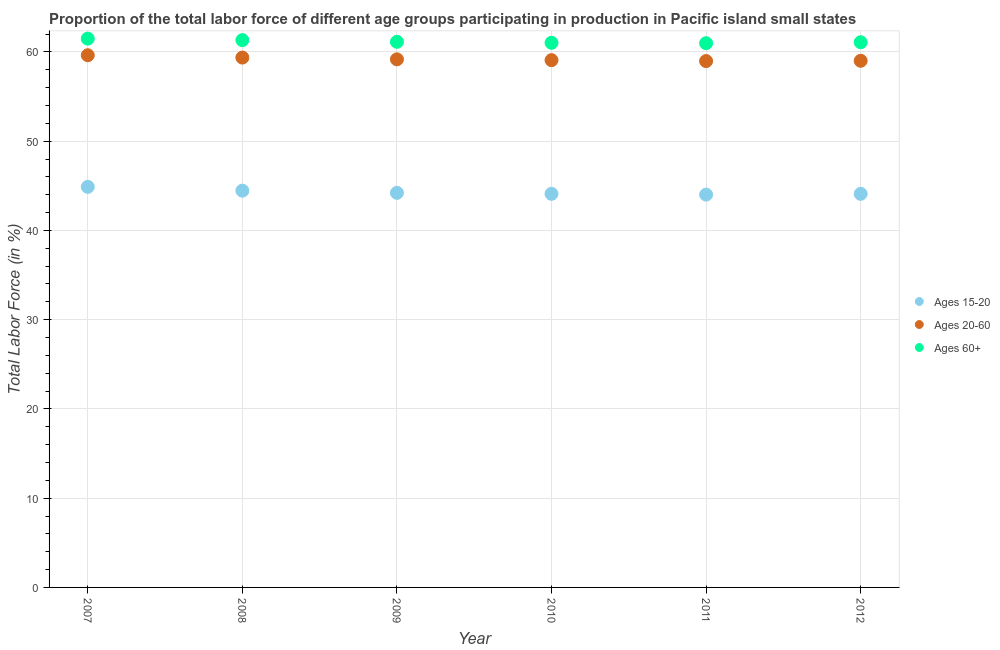What is the percentage of labor force within the age group 20-60 in 2010?
Keep it short and to the point. 59.08. Across all years, what is the maximum percentage of labor force above age 60?
Offer a very short reply. 61.49. Across all years, what is the minimum percentage of labor force within the age group 15-20?
Your answer should be very brief. 44.01. In which year was the percentage of labor force within the age group 20-60 maximum?
Offer a terse response. 2007. In which year was the percentage of labor force within the age group 20-60 minimum?
Provide a short and direct response. 2011. What is the total percentage of labor force above age 60 in the graph?
Provide a short and direct response. 367.02. What is the difference between the percentage of labor force within the age group 15-20 in 2008 and that in 2009?
Your response must be concise. 0.24. What is the difference between the percentage of labor force above age 60 in 2007 and the percentage of labor force within the age group 15-20 in 2008?
Make the answer very short. 17.04. What is the average percentage of labor force within the age group 20-60 per year?
Make the answer very short. 59.2. In the year 2012, what is the difference between the percentage of labor force within the age group 15-20 and percentage of labor force above age 60?
Make the answer very short. -16.99. What is the ratio of the percentage of labor force above age 60 in 2007 to that in 2010?
Your answer should be compact. 1.01. What is the difference between the highest and the second highest percentage of labor force within the age group 20-60?
Provide a short and direct response. 0.26. What is the difference between the highest and the lowest percentage of labor force within the age group 20-60?
Give a very brief answer. 0.65. In how many years, is the percentage of labor force within the age group 15-20 greater than the average percentage of labor force within the age group 15-20 taken over all years?
Provide a short and direct response. 2. Is it the case that in every year, the sum of the percentage of labor force within the age group 15-20 and percentage of labor force within the age group 20-60 is greater than the percentage of labor force above age 60?
Keep it short and to the point. Yes. How many years are there in the graph?
Ensure brevity in your answer.  6. Are the values on the major ticks of Y-axis written in scientific E-notation?
Your response must be concise. No. Does the graph contain any zero values?
Your answer should be very brief. No. Where does the legend appear in the graph?
Ensure brevity in your answer.  Center right. How many legend labels are there?
Your answer should be very brief. 3. What is the title of the graph?
Your response must be concise. Proportion of the total labor force of different age groups participating in production in Pacific island small states. What is the Total Labor Force (in %) of Ages 15-20 in 2007?
Your answer should be compact. 44.88. What is the Total Labor Force (in %) in Ages 20-60 in 2007?
Your response must be concise. 59.63. What is the Total Labor Force (in %) in Ages 60+ in 2007?
Keep it short and to the point. 61.49. What is the Total Labor Force (in %) in Ages 15-20 in 2008?
Your response must be concise. 44.45. What is the Total Labor Force (in %) in Ages 20-60 in 2008?
Your response must be concise. 59.36. What is the Total Labor Force (in %) of Ages 60+ in 2008?
Provide a succinct answer. 61.32. What is the Total Labor Force (in %) in Ages 15-20 in 2009?
Your answer should be compact. 44.21. What is the Total Labor Force (in %) of Ages 20-60 in 2009?
Provide a succinct answer. 59.17. What is the Total Labor Force (in %) in Ages 60+ in 2009?
Ensure brevity in your answer.  61.13. What is the Total Labor Force (in %) in Ages 15-20 in 2010?
Give a very brief answer. 44.1. What is the Total Labor Force (in %) of Ages 20-60 in 2010?
Keep it short and to the point. 59.08. What is the Total Labor Force (in %) in Ages 60+ in 2010?
Offer a terse response. 61.02. What is the Total Labor Force (in %) of Ages 15-20 in 2011?
Provide a succinct answer. 44.01. What is the Total Labor Force (in %) in Ages 20-60 in 2011?
Your response must be concise. 58.97. What is the Total Labor Force (in %) of Ages 60+ in 2011?
Make the answer very short. 60.97. What is the Total Labor Force (in %) in Ages 15-20 in 2012?
Offer a terse response. 44.1. What is the Total Labor Force (in %) of Ages 20-60 in 2012?
Provide a short and direct response. 59.01. What is the Total Labor Force (in %) of Ages 60+ in 2012?
Your answer should be compact. 61.09. Across all years, what is the maximum Total Labor Force (in %) in Ages 15-20?
Keep it short and to the point. 44.88. Across all years, what is the maximum Total Labor Force (in %) of Ages 20-60?
Ensure brevity in your answer.  59.63. Across all years, what is the maximum Total Labor Force (in %) of Ages 60+?
Keep it short and to the point. 61.49. Across all years, what is the minimum Total Labor Force (in %) in Ages 15-20?
Keep it short and to the point. 44.01. Across all years, what is the minimum Total Labor Force (in %) in Ages 20-60?
Provide a succinct answer. 58.97. Across all years, what is the minimum Total Labor Force (in %) in Ages 60+?
Make the answer very short. 60.97. What is the total Total Labor Force (in %) in Ages 15-20 in the graph?
Ensure brevity in your answer.  265.75. What is the total Total Labor Force (in %) in Ages 20-60 in the graph?
Give a very brief answer. 355.22. What is the total Total Labor Force (in %) in Ages 60+ in the graph?
Your response must be concise. 367.02. What is the difference between the Total Labor Force (in %) of Ages 15-20 in 2007 and that in 2008?
Offer a terse response. 0.43. What is the difference between the Total Labor Force (in %) in Ages 20-60 in 2007 and that in 2008?
Ensure brevity in your answer.  0.26. What is the difference between the Total Labor Force (in %) in Ages 60+ in 2007 and that in 2008?
Make the answer very short. 0.17. What is the difference between the Total Labor Force (in %) in Ages 15-20 in 2007 and that in 2009?
Offer a very short reply. 0.67. What is the difference between the Total Labor Force (in %) in Ages 20-60 in 2007 and that in 2009?
Your response must be concise. 0.46. What is the difference between the Total Labor Force (in %) in Ages 60+ in 2007 and that in 2009?
Provide a succinct answer. 0.36. What is the difference between the Total Labor Force (in %) of Ages 15-20 in 2007 and that in 2010?
Your answer should be very brief. 0.78. What is the difference between the Total Labor Force (in %) of Ages 20-60 in 2007 and that in 2010?
Keep it short and to the point. 0.55. What is the difference between the Total Labor Force (in %) in Ages 60+ in 2007 and that in 2010?
Provide a short and direct response. 0.47. What is the difference between the Total Labor Force (in %) in Ages 15-20 in 2007 and that in 2011?
Make the answer very short. 0.87. What is the difference between the Total Labor Force (in %) of Ages 20-60 in 2007 and that in 2011?
Your answer should be compact. 0.65. What is the difference between the Total Labor Force (in %) of Ages 60+ in 2007 and that in 2011?
Offer a terse response. 0.51. What is the difference between the Total Labor Force (in %) of Ages 15-20 in 2007 and that in 2012?
Offer a very short reply. 0.78. What is the difference between the Total Labor Force (in %) of Ages 20-60 in 2007 and that in 2012?
Keep it short and to the point. 0.62. What is the difference between the Total Labor Force (in %) in Ages 60+ in 2007 and that in 2012?
Provide a short and direct response. 0.4. What is the difference between the Total Labor Force (in %) in Ages 15-20 in 2008 and that in 2009?
Make the answer very short. 0.24. What is the difference between the Total Labor Force (in %) in Ages 20-60 in 2008 and that in 2009?
Provide a succinct answer. 0.2. What is the difference between the Total Labor Force (in %) of Ages 60+ in 2008 and that in 2009?
Your answer should be very brief. 0.19. What is the difference between the Total Labor Force (in %) in Ages 15-20 in 2008 and that in 2010?
Provide a succinct answer. 0.35. What is the difference between the Total Labor Force (in %) in Ages 20-60 in 2008 and that in 2010?
Provide a short and direct response. 0.29. What is the difference between the Total Labor Force (in %) of Ages 60+ in 2008 and that in 2010?
Ensure brevity in your answer.  0.3. What is the difference between the Total Labor Force (in %) of Ages 15-20 in 2008 and that in 2011?
Your answer should be compact. 0.44. What is the difference between the Total Labor Force (in %) in Ages 20-60 in 2008 and that in 2011?
Provide a short and direct response. 0.39. What is the difference between the Total Labor Force (in %) in Ages 60+ in 2008 and that in 2011?
Provide a succinct answer. 0.35. What is the difference between the Total Labor Force (in %) of Ages 15-20 in 2008 and that in 2012?
Make the answer very short. 0.36. What is the difference between the Total Labor Force (in %) in Ages 20-60 in 2008 and that in 2012?
Offer a very short reply. 0.36. What is the difference between the Total Labor Force (in %) in Ages 60+ in 2008 and that in 2012?
Make the answer very short. 0.24. What is the difference between the Total Labor Force (in %) of Ages 15-20 in 2009 and that in 2010?
Your answer should be very brief. 0.11. What is the difference between the Total Labor Force (in %) in Ages 20-60 in 2009 and that in 2010?
Provide a succinct answer. 0.09. What is the difference between the Total Labor Force (in %) in Ages 60+ in 2009 and that in 2010?
Offer a very short reply. 0.11. What is the difference between the Total Labor Force (in %) of Ages 15-20 in 2009 and that in 2011?
Provide a succinct answer. 0.2. What is the difference between the Total Labor Force (in %) in Ages 20-60 in 2009 and that in 2011?
Give a very brief answer. 0.2. What is the difference between the Total Labor Force (in %) in Ages 60+ in 2009 and that in 2011?
Keep it short and to the point. 0.16. What is the difference between the Total Labor Force (in %) of Ages 15-20 in 2009 and that in 2012?
Your response must be concise. 0.11. What is the difference between the Total Labor Force (in %) of Ages 20-60 in 2009 and that in 2012?
Keep it short and to the point. 0.16. What is the difference between the Total Labor Force (in %) of Ages 60+ in 2009 and that in 2012?
Provide a short and direct response. 0.04. What is the difference between the Total Labor Force (in %) in Ages 15-20 in 2010 and that in 2011?
Give a very brief answer. 0.09. What is the difference between the Total Labor Force (in %) of Ages 20-60 in 2010 and that in 2011?
Offer a terse response. 0.1. What is the difference between the Total Labor Force (in %) of Ages 60+ in 2010 and that in 2011?
Provide a short and direct response. 0.05. What is the difference between the Total Labor Force (in %) of Ages 15-20 in 2010 and that in 2012?
Your response must be concise. 0. What is the difference between the Total Labor Force (in %) of Ages 20-60 in 2010 and that in 2012?
Make the answer very short. 0.07. What is the difference between the Total Labor Force (in %) in Ages 60+ in 2010 and that in 2012?
Offer a very short reply. -0.06. What is the difference between the Total Labor Force (in %) of Ages 15-20 in 2011 and that in 2012?
Your answer should be very brief. -0.09. What is the difference between the Total Labor Force (in %) in Ages 20-60 in 2011 and that in 2012?
Provide a succinct answer. -0.03. What is the difference between the Total Labor Force (in %) in Ages 60+ in 2011 and that in 2012?
Provide a succinct answer. -0.11. What is the difference between the Total Labor Force (in %) in Ages 15-20 in 2007 and the Total Labor Force (in %) in Ages 20-60 in 2008?
Offer a terse response. -14.48. What is the difference between the Total Labor Force (in %) of Ages 15-20 in 2007 and the Total Labor Force (in %) of Ages 60+ in 2008?
Your answer should be very brief. -16.44. What is the difference between the Total Labor Force (in %) in Ages 20-60 in 2007 and the Total Labor Force (in %) in Ages 60+ in 2008?
Make the answer very short. -1.69. What is the difference between the Total Labor Force (in %) of Ages 15-20 in 2007 and the Total Labor Force (in %) of Ages 20-60 in 2009?
Keep it short and to the point. -14.29. What is the difference between the Total Labor Force (in %) in Ages 15-20 in 2007 and the Total Labor Force (in %) in Ages 60+ in 2009?
Provide a short and direct response. -16.25. What is the difference between the Total Labor Force (in %) in Ages 20-60 in 2007 and the Total Labor Force (in %) in Ages 60+ in 2009?
Offer a very short reply. -1.5. What is the difference between the Total Labor Force (in %) of Ages 15-20 in 2007 and the Total Labor Force (in %) of Ages 20-60 in 2010?
Provide a succinct answer. -14.2. What is the difference between the Total Labor Force (in %) of Ages 15-20 in 2007 and the Total Labor Force (in %) of Ages 60+ in 2010?
Give a very brief answer. -16.14. What is the difference between the Total Labor Force (in %) in Ages 20-60 in 2007 and the Total Labor Force (in %) in Ages 60+ in 2010?
Provide a short and direct response. -1.39. What is the difference between the Total Labor Force (in %) of Ages 15-20 in 2007 and the Total Labor Force (in %) of Ages 20-60 in 2011?
Your response must be concise. -14.09. What is the difference between the Total Labor Force (in %) of Ages 15-20 in 2007 and the Total Labor Force (in %) of Ages 60+ in 2011?
Keep it short and to the point. -16.09. What is the difference between the Total Labor Force (in %) of Ages 20-60 in 2007 and the Total Labor Force (in %) of Ages 60+ in 2011?
Your answer should be very brief. -1.35. What is the difference between the Total Labor Force (in %) of Ages 15-20 in 2007 and the Total Labor Force (in %) of Ages 20-60 in 2012?
Your response must be concise. -14.13. What is the difference between the Total Labor Force (in %) of Ages 15-20 in 2007 and the Total Labor Force (in %) of Ages 60+ in 2012?
Provide a succinct answer. -16.2. What is the difference between the Total Labor Force (in %) in Ages 20-60 in 2007 and the Total Labor Force (in %) in Ages 60+ in 2012?
Provide a short and direct response. -1.46. What is the difference between the Total Labor Force (in %) of Ages 15-20 in 2008 and the Total Labor Force (in %) of Ages 20-60 in 2009?
Give a very brief answer. -14.72. What is the difference between the Total Labor Force (in %) of Ages 15-20 in 2008 and the Total Labor Force (in %) of Ages 60+ in 2009?
Your response must be concise. -16.68. What is the difference between the Total Labor Force (in %) in Ages 20-60 in 2008 and the Total Labor Force (in %) in Ages 60+ in 2009?
Your response must be concise. -1.77. What is the difference between the Total Labor Force (in %) of Ages 15-20 in 2008 and the Total Labor Force (in %) of Ages 20-60 in 2010?
Provide a short and direct response. -14.62. What is the difference between the Total Labor Force (in %) of Ages 15-20 in 2008 and the Total Labor Force (in %) of Ages 60+ in 2010?
Your response must be concise. -16.57. What is the difference between the Total Labor Force (in %) of Ages 20-60 in 2008 and the Total Labor Force (in %) of Ages 60+ in 2010?
Your answer should be very brief. -1.66. What is the difference between the Total Labor Force (in %) of Ages 15-20 in 2008 and the Total Labor Force (in %) of Ages 20-60 in 2011?
Ensure brevity in your answer.  -14.52. What is the difference between the Total Labor Force (in %) of Ages 15-20 in 2008 and the Total Labor Force (in %) of Ages 60+ in 2011?
Ensure brevity in your answer.  -16.52. What is the difference between the Total Labor Force (in %) of Ages 20-60 in 2008 and the Total Labor Force (in %) of Ages 60+ in 2011?
Your response must be concise. -1.61. What is the difference between the Total Labor Force (in %) in Ages 15-20 in 2008 and the Total Labor Force (in %) in Ages 20-60 in 2012?
Your answer should be compact. -14.55. What is the difference between the Total Labor Force (in %) of Ages 15-20 in 2008 and the Total Labor Force (in %) of Ages 60+ in 2012?
Offer a very short reply. -16.63. What is the difference between the Total Labor Force (in %) of Ages 20-60 in 2008 and the Total Labor Force (in %) of Ages 60+ in 2012?
Provide a short and direct response. -1.72. What is the difference between the Total Labor Force (in %) in Ages 15-20 in 2009 and the Total Labor Force (in %) in Ages 20-60 in 2010?
Give a very brief answer. -14.87. What is the difference between the Total Labor Force (in %) in Ages 15-20 in 2009 and the Total Labor Force (in %) in Ages 60+ in 2010?
Your answer should be very brief. -16.81. What is the difference between the Total Labor Force (in %) in Ages 20-60 in 2009 and the Total Labor Force (in %) in Ages 60+ in 2010?
Your answer should be compact. -1.85. What is the difference between the Total Labor Force (in %) in Ages 15-20 in 2009 and the Total Labor Force (in %) in Ages 20-60 in 2011?
Your response must be concise. -14.76. What is the difference between the Total Labor Force (in %) in Ages 15-20 in 2009 and the Total Labor Force (in %) in Ages 60+ in 2011?
Make the answer very short. -16.76. What is the difference between the Total Labor Force (in %) in Ages 20-60 in 2009 and the Total Labor Force (in %) in Ages 60+ in 2011?
Make the answer very short. -1.81. What is the difference between the Total Labor Force (in %) of Ages 15-20 in 2009 and the Total Labor Force (in %) of Ages 20-60 in 2012?
Your answer should be compact. -14.8. What is the difference between the Total Labor Force (in %) in Ages 15-20 in 2009 and the Total Labor Force (in %) in Ages 60+ in 2012?
Your answer should be very brief. -16.88. What is the difference between the Total Labor Force (in %) of Ages 20-60 in 2009 and the Total Labor Force (in %) of Ages 60+ in 2012?
Offer a terse response. -1.92. What is the difference between the Total Labor Force (in %) in Ages 15-20 in 2010 and the Total Labor Force (in %) in Ages 20-60 in 2011?
Ensure brevity in your answer.  -14.87. What is the difference between the Total Labor Force (in %) in Ages 15-20 in 2010 and the Total Labor Force (in %) in Ages 60+ in 2011?
Offer a very short reply. -16.87. What is the difference between the Total Labor Force (in %) of Ages 20-60 in 2010 and the Total Labor Force (in %) of Ages 60+ in 2011?
Your response must be concise. -1.9. What is the difference between the Total Labor Force (in %) in Ages 15-20 in 2010 and the Total Labor Force (in %) in Ages 20-60 in 2012?
Your response must be concise. -14.91. What is the difference between the Total Labor Force (in %) of Ages 15-20 in 2010 and the Total Labor Force (in %) of Ages 60+ in 2012?
Keep it short and to the point. -16.99. What is the difference between the Total Labor Force (in %) in Ages 20-60 in 2010 and the Total Labor Force (in %) in Ages 60+ in 2012?
Offer a terse response. -2.01. What is the difference between the Total Labor Force (in %) in Ages 15-20 in 2011 and the Total Labor Force (in %) in Ages 20-60 in 2012?
Ensure brevity in your answer.  -14.99. What is the difference between the Total Labor Force (in %) in Ages 15-20 in 2011 and the Total Labor Force (in %) in Ages 60+ in 2012?
Offer a terse response. -17.07. What is the difference between the Total Labor Force (in %) in Ages 20-60 in 2011 and the Total Labor Force (in %) in Ages 60+ in 2012?
Provide a short and direct response. -2.11. What is the average Total Labor Force (in %) in Ages 15-20 per year?
Give a very brief answer. 44.29. What is the average Total Labor Force (in %) of Ages 20-60 per year?
Ensure brevity in your answer.  59.2. What is the average Total Labor Force (in %) of Ages 60+ per year?
Offer a terse response. 61.17. In the year 2007, what is the difference between the Total Labor Force (in %) of Ages 15-20 and Total Labor Force (in %) of Ages 20-60?
Ensure brevity in your answer.  -14.75. In the year 2007, what is the difference between the Total Labor Force (in %) of Ages 15-20 and Total Labor Force (in %) of Ages 60+?
Offer a very short reply. -16.61. In the year 2007, what is the difference between the Total Labor Force (in %) in Ages 20-60 and Total Labor Force (in %) in Ages 60+?
Provide a short and direct response. -1.86. In the year 2008, what is the difference between the Total Labor Force (in %) in Ages 15-20 and Total Labor Force (in %) in Ages 20-60?
Your response must be concise. -14.91. In the year 2008, what is the difference between the Total Labor Force (in %) in Ages 15-20 and Total Labor Force (in %) in Ages 60+?
Give a very brief answer. -16.87. In the year 2008, what is the difference between the Total Labor Force (in %) in Ages 20-60 and Total Labor Force (in %) in Ages 60+?
Your answer should be very brief. -1.96. In the year 2009, what is the difference between the Total Labor Force (in %) in Ages 15-20 and Total Labor Force (in %) in Ages 20-60?
Your answer should be compact. -14.96. In the year 2009, what is the difference between the Total Labor Force (in %) in Ages 15-20 and Total Labor Force (in %) in Ages 60+?
Your response must be concise. -16.92. In the year 2009, what is the difference between the Total Labor Force (in %) in Ages 20-60 and Total Labor Force (in %) in Ages 60+?
Provide a succinct answer. -1.96. In the year 2010, what is the difference between the Total Labor Force (in %) in Ages 15-20 and Total Labor Force (in %) in Ages 20-60?
Offer a very short reply. -14.98. In the year 2010, what is the difference between the Total Labor Force (in %) of Ages 15-20 and Total Labor Force (in %) of Ages 60+?
Offer a terse response. -16.92. In the year 2010, what is the difference between the Total Labor Force (in %) in Ages 20-60 and Total Labor Force (in %) in Ages 60+?
Offer a terse response. -1.94. In the year 2011, what is the difference between the Total Labor Force (in %) in Ages 15-20 and Total Labor Force (in %) in Ages 20-60?
Your answer should be very brief. -14.96. In the year 2011, what is the difference between the Total Labor Force (in %) of Ages 15-20 and Total Labor Force (in %) of Ages 60+?
Offer a terse response. -16.96. In the year 2011, what is the difference between the Total Labor Force (in %) in Ages 20-60 and Total Labor Force (in %) in Ages 60+?
Your answer should be compact. -2. In the year 2012, what is the difference between the Total Labor Force (in %) of Ages 15-20 and Total Labor Force (in %) of Ages 20-60?
Provide a short and direct response. -14.91. In the year 2012, what is the difference between the Total Labor Force (in %) of Ages 15-20 and Total Labor Force (in %) of Ages 60+?
Offer a very short reply. -16.99. In the year 2012, what is the difference between the Total Labor Force (in %) of Ages 20-60 and Total Labor Force (in %) of Ages 60+?
Provide a succinct answer. -2.08. What is the ratio of the Total Labor Force (in %) of Ages 15-20 in 2007 to that in 2008?
Give a very brief answer. 1.01. What is the ratio of the Total Labor Force (in %) in Ages 20-60 in 2007 to that in 2008?
Your answer should be very brief. 1. What is the ratio of the Total Labor Force (in %) in Ages 60+ in 2007 to that in 2008?
Provide a succinct answer. 1. What is the ratio of the Total Labor Force (in %) of Ages 15-20 in 2007 to that in 2009?
Offer a terse response. 1.02. What is the ratio of the Total Labor Force (in %) of Ages 20-60 in 2007 to that in 2009?
Make the answer very short. 1.01. What is the ratio of the Total Labor Force (in %) of Ages 60+ in 2007 to that in 2009?
Keep it short and to the point. 1.01. What is the ratio of the Total Labor Force (in %) of Ages 15-20 in 2007 to that in 2010?
Provide a succinct answer. 1.02. What is the ratio of the Total Labor Force (in %) in Ages 20-60 in 2007 to that in 2010?
Provide a succinct answer. 1.01. What is the ratio of the Total Labor Force (in %) in Ages 60+ in 2007 to that in 2010?
Keep it short and to the point. 1.01. What is the ratio of the Total Labor Force (in %) of Ages 15-20 in 2007 to that in 2011?
Your answer should be very brief. 1.02. What is the ratio of the Total Labor Force (in %) of Ages 20-60 in 2007 to that in 2011?
Offer a terse response. 1.01. What is the ratio of the Total Labor Force (in %) of Ages 60+ in 2007 to that in 2011?
Keep it short and to the point. 1.01. What is the ratio of the Total Labor Force (in %) of Ages 15-20 in 2007 to that in 2012?
Offer a terse response. 1.02. What is the ratio of the Total Labor Force (in %) in Ages 20-60 in 2007 to that in 2012?
Give a very brief answer. 1.01. What is the ratio of the Total Labor Force (in %) of Ages 60+ in 2007 to that in 2012?
Provide a short and direct response. 1.01. What is the ratio of the Total Labor Force (in %) of Ages 20-60 in 2008 to that in 2009?
Your answer should be compact. 1. What is the ratio of the Total Labor Force (in %) of Ages 60+ in 2008 to that in 2009?
Provide a succinct answer. 1. What is the ratio of the Total Labor Force (in %) in Ages 15-20 in 2008 to that in 2010?
Your answer should be very brief. 1.01. What is the ratio of the Total Labor Force (in %) in Ages 60+ in 2008 to that in 2010?
Offer a terse response. 1. What is the ratio of the Total Labor Force (in %) in Ages 20-60 in 2008 to that in 2011?
Your answer should be compact. 1.01. What is the ratio of the Total Labor Force (in %) of Ages 60+ in 2008 to that in 2012?
Provide a succinct answer. 1. What is the ratio of the Total Labor Force (in %) in Ages 15-20 in 2009 to that in 2011?
Keep it short and to the point. 1. What is the ratio of the Total Labor Force (in %) of Ages 60+ in 2009 to that in 2011?
Your answer should be compact. 1. What is the ratio of the Total Labor Force (in %) of Ages 20-60 in 2010 to that in 2011?
Your answer should be very brief. 1. What is the ratio of the Total Labor Force (in %) of Ages 60+ in 2010 to that in 2011?
Make the answer very short. 1. What is the ratio of the Total Labor Force (in %) in Ages 60+ in 2010 to that in 2012?
Provide a short and direct response. 1. What is the ratio of the Total Labor Force (in %) in Ages 15-20 in 2011 to that in 2012?
Provide a short and direct response. 1. What is the ratio of the Total Labor Force (in %) in Ages 60+ in 2011 to that in 2012?
Your response must be concise. 1. What is the difference between the highest and the second highest Total Labor Force (in %) of Ages 15-20?
Make the answer very short. 0.43. What is the difference between the highest and the second highest Total Labor Force (in %) in Ages 20-60?
Offer a very short reply. 0.26. What is the difference between the highest and the second highest Total Labor Force (in %) in Ages 60+?
Provide a short and direct response. 0.17. What is the difference between the highest and the lowest Total Labor Force (in %) of Ages 15-20?
Give a very brief answer. 0.87. What is the difference between the highest and the lowest Total Labor Force (in %) of Ages 20-60?
Ensure brevity in your answer.  0.65. What is the difference between the highest and the lowest Total Labor Force (in %) of Ages 60+?
Offer a terse response. 0.51. 